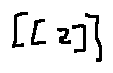Convert formula to latex. <formula><loc_0><loc_0><loc_500><loc_500>[ [ z ] ]</formula> 